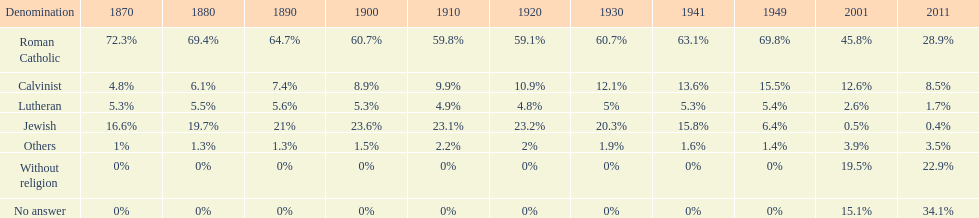What is the complete percentage of persons who recognized themselves as religious in 2011? 43%. 